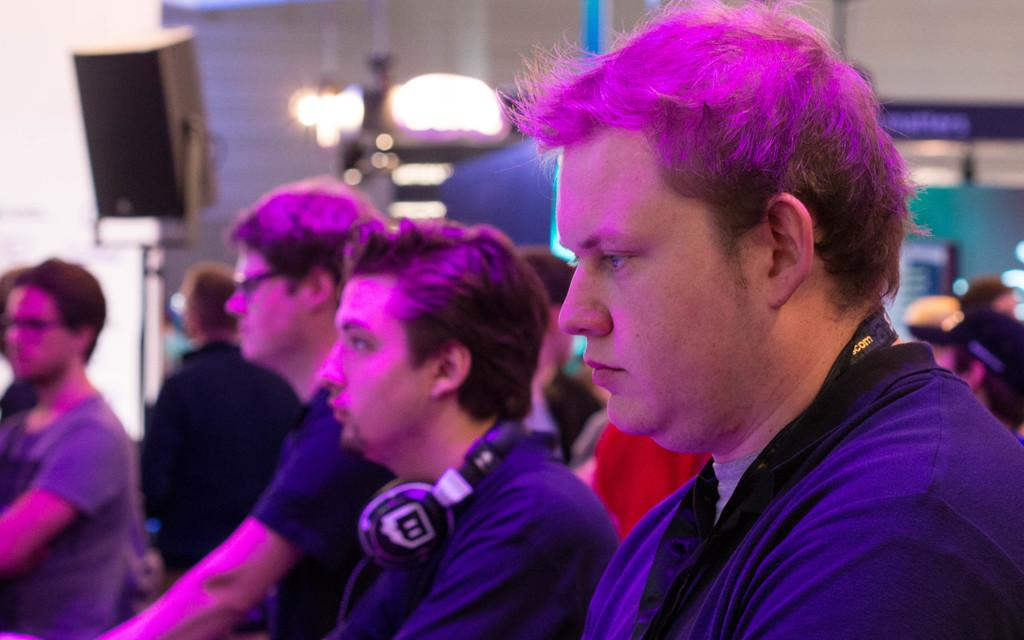Who or what can be seen in the image? There are people in the image. What can be seen in the background of the image? There is a speaker in the background of the image. What is the setting of the image? There is a wall in the image, which suggests an indoor setting. What type of window can be seen in the image? There is no window present in the image. How do the people in the image react to the speaker? The image does not show the people's reactions to the speaker, so it cannot be determined from the image. 